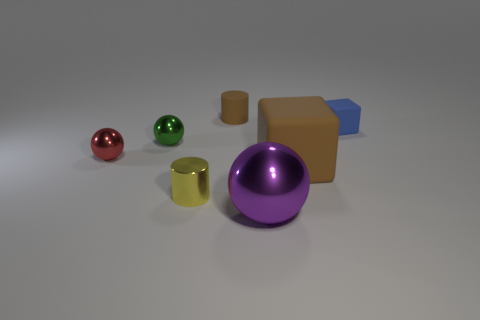Are there any large purple metal things in front of the green ball?
Make the answer very short. Yes. What material is the large ball?
Your response must be concise. Metal. Is the color of the rubber object in front of the small red metal object the same as the rubber cylinder?
Ensure brevity in your answer.  Yes. What is the color of the small metallic object that is the same shape as the tiny brown matte thing?
Ensure brevity in your answer.  Yellow. What material is the ball that is on the right side of the tiny green thing?
Your response must be concise. Metal. What color is the small block?
Keep it short and to the point. Blue. There is a brown rubber object in front of the green object; is it the same size as the blue cube?
Give a very brief answer. No. The small cylinder in front of the rubber object behind the cube behind the big brown block is made of what material?
Provide a short and direct response. Metal. Do the cylinder that is behind the green metal thing and the big thing that is right of the big purple metal sphere have the same color?
Keep it short and to the point. Yes. The tiny cylinder behind the small cylinder in front of the small brown object is made of what material?
Your answer should be compact. Rubber. 